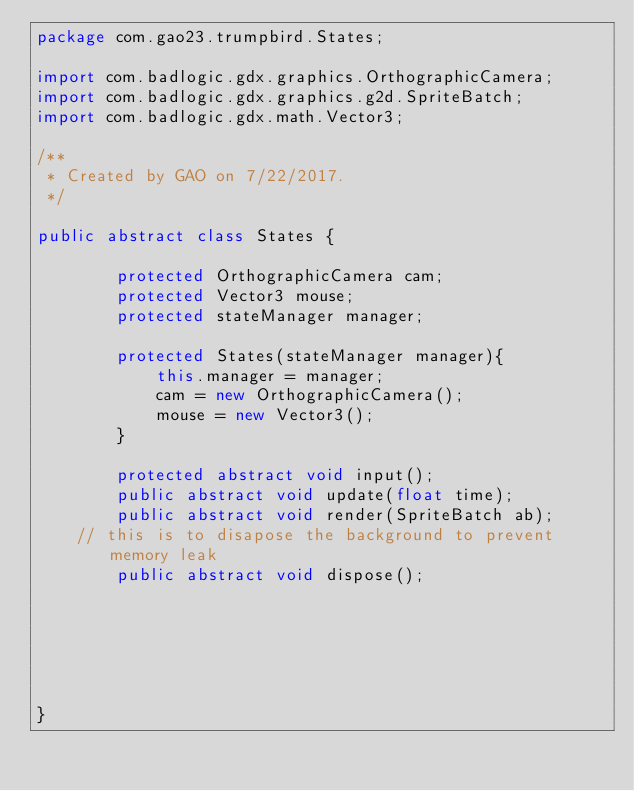<code> <loc_0><loc_0><loc_500><loc_500><_Java_>package com.gao23.trumpbird.States;

import com.badlogic.gdx.graphics.OrthographicCamera;
import com.badlogic.gdx.graphics.g2d.SpriteBatch;
import com.badlogic.gdx.math.Vector3;

/**
 * Created by GAO on 7/22/2017.
 */

public abstract class States {

        protected OrthographicCamera cam;
        protected Vector3 mouse;
        protected stateManager manager;

        protected States(stateManager manager){
            this.manager = manager;
            cam = new OrthographicCamera();
            mouse = new Vector3();
        }

        protected abstract void input();
        public abstract void update(float time);
        public abstract void render(SpriteBatch ab);
    // this is to disapose the background to prevent memory leak
        public abstract void dispose();






}
</code> 